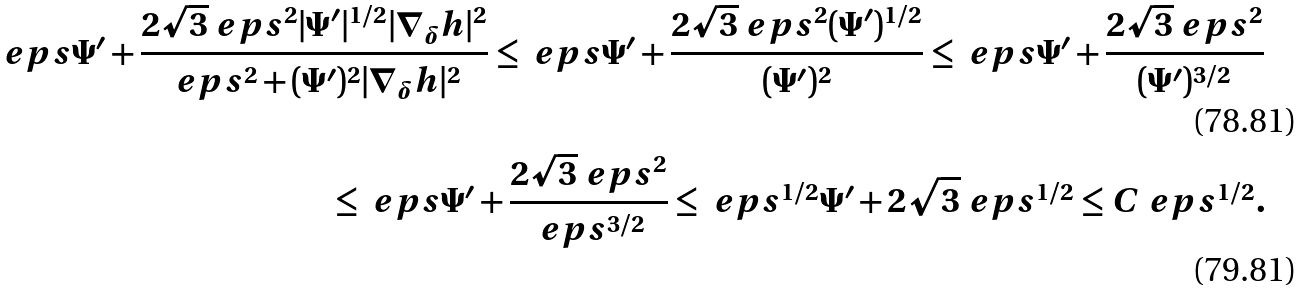<formula> <loc_0><loc_0><loc_500><loc_500>\ e p s \Psi ^ { \prime } + \frac { 2 \sqrt { 3 } \ e p s ^ { 2 } | \Psi ^ { \prime } | ^ { 1 / 2 } | \nabla _ { \delta } h | ^ { 2 } } { \ e p s ^ { 2 } + ( \Psi ^ { \prime } ) ^ { 2 } | \nabla _ { \delta } h | ^ { 2 } } \leq \ e p s \Psi ^ { \prime } + \frac { 2 \sqrt { 3 } \ e p s ^ { 2 } ( \Psi ^ { \prime } ) ^ { 1 / 2 } } { ( \Psi ^ { \prime } ) ^ { 2 } } \leq \ e p s \Psi ^ { \prime } + \frac { 2 \sqrt { 3 } \ e p s ^ { 2 } } { ( \Psi ^ { \prime } ) ^ { 3 / 2 } } \\ \leq \ e p s \Psi ^ { \prime } + \frac { 2 \sqrt { 3 } \ e p s ^ { 2 } } { \ e p s ^ { 3 / 2 } } \leq \ e p s ^ { 1 / 2 } \Psi ^ { \prime } + 2 \sqrt { 3 } \ e p s ^ { 1 / 2 } \leq C \ e p s ^ { 1 / 2 } .</formula> 